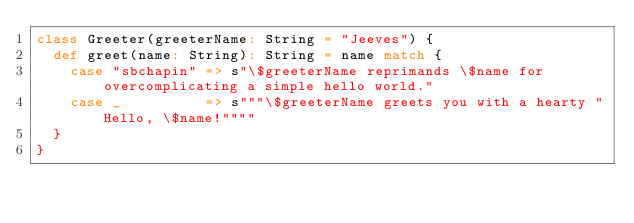Convert code to text. <code><loc_0><loc_0><loc_500><loc_500><_Scala_>class Greeter(greeterName: String = "Jeeves") {
  def greet(name: String): String = name match {
    case "sbchapin" => s"\$greeterName reprimands \$name for overcomplicating a simple hello world."
    case _          => s"""\$greeterName greets you with a hearty "Hello, \$name!""""
  }
}
</code> 